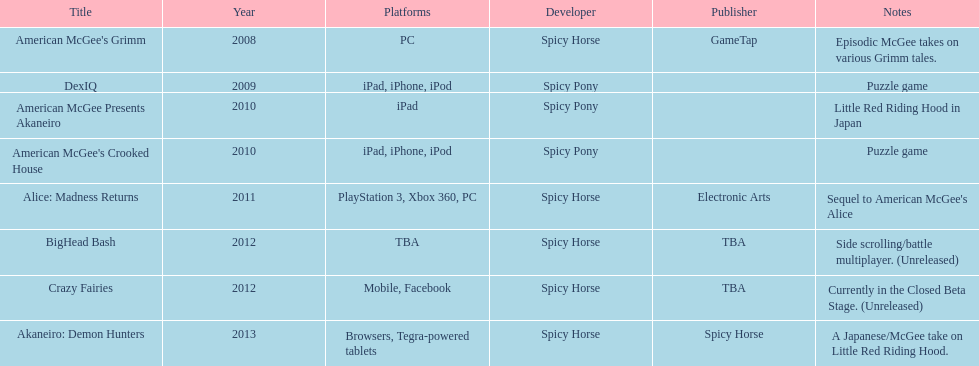Which title is for ipad but not for iphone or ipod? American McGee Presents Akaneiro. 